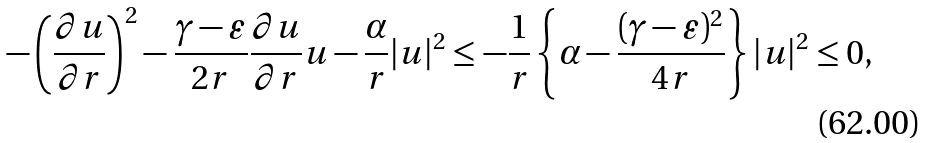Convert formula to latex. <formula><loc_0><loc_0><loc_500><loc_500>- \left ( \frac { \partial u } { \partial r } \right ) ^ { 2 } - \frac { \gamma - \varepsilon } { 2 r } \frac { \partial u } { \partial r } u - \frac { \alpha } { r } | u | ^ { 2 } \leq - \frac { 1 } { r } \left \{ \alpha - \frac { ( \gamma - \varepsilon ) ^ { 2 } } { 4 r } \right \} | u | ^ { 2 } \leq 0 ,</formula> 